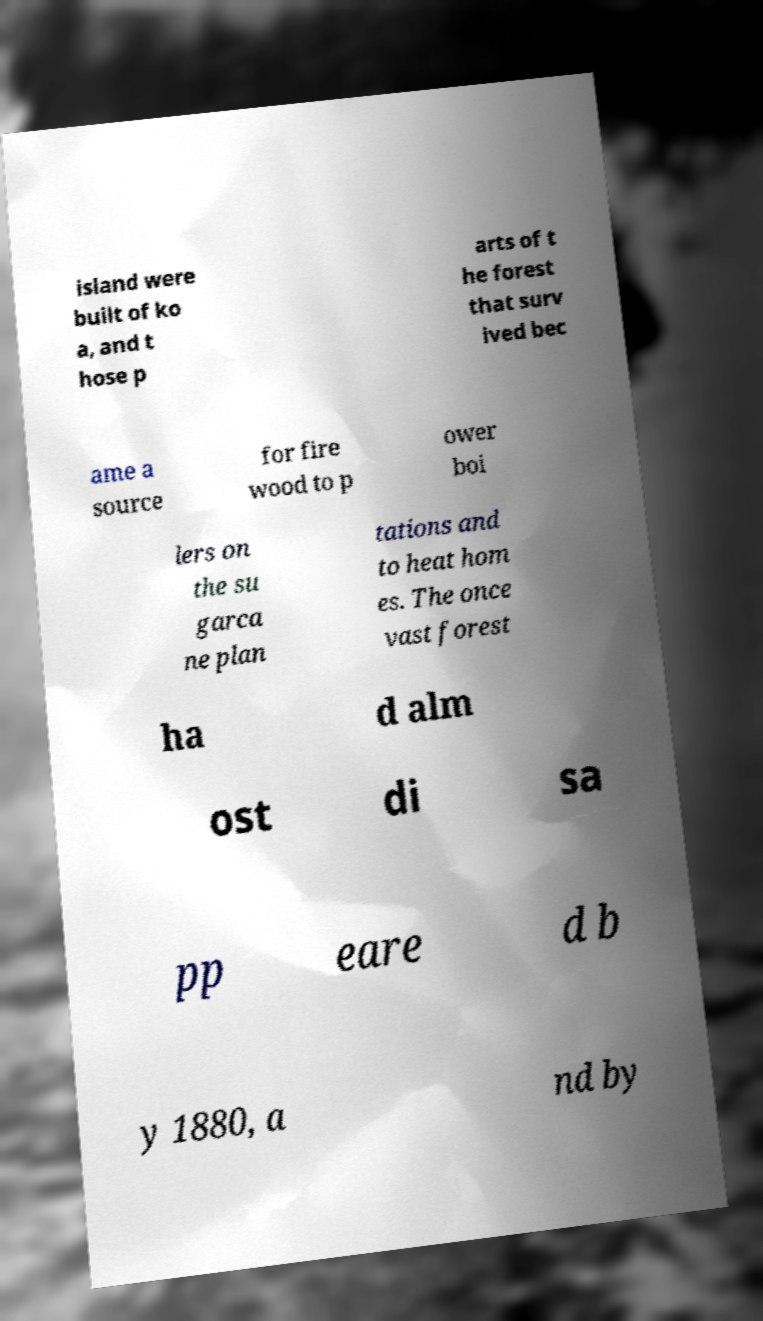Please read and relay the text visible in this image. What does it say? island were built of ko a, and t hose p arts of t he forest that surv ived bec ame a source for fire wood to p ower boi lers on the su garca ne plan tations and to heat hom es. The once vast forest ha d alm ost di sa pp eare d b y 1880, a nd by 